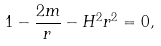Convert formula to latex. <formula><loc_0><loc_0><loc_500><loc_500>1 - \frac { 2 m } { r } - H ^ { 2 } r ^ { 2 } = 0 ,</formula> 